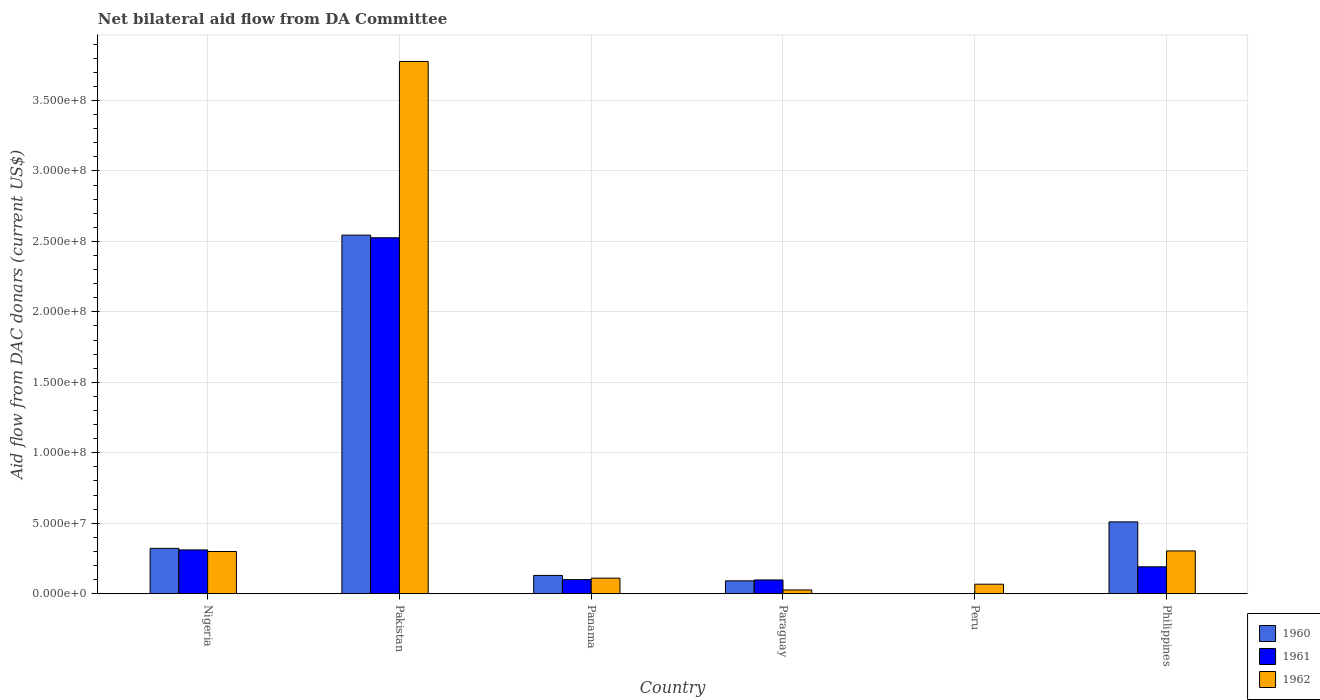How many different coloured bars are there?
Offer a very short reply. 3. What is the label of the 3rd group of bars from the left?
Your answer should be compact. Panama. What is the aid flow in in 1960 in Paraguay?
Your response must be concise. 9.10e+06. Across all countries, what is the maximum aid flow in in 1961?
Provide a succinct answer. 2.53e+08. Across all countries, what is the minimum aid flow in in 1961?
Your response must be concise. 0. In which country was the aid flow in in 1960 maximum?
Offer a very short reply. Pakistan. What is the total aid flow in in 1960 in the graph?
Your response must be concise. 3.60e+08. What is the difference between the aid flow in in 1962 in Pakistan and that in Panama?
Offer a very short reply. 3.67e+08. What is the difference between the aid flow in in 1961 in Peru and the aid flow in in 1960 in Pakistan?
Make the answer very short. -2.54e+08. What is the average aid flow in in 1961 per country?
Your answer should be very brief. 5.37e+07. What is the difference between the aid flow in of/in 1962 and aid flow in of/in 1961 in Nigeria?
Provide a succinct answer. -1.12e+06. In how many countries, is the aid flow in in 1962 greater than 250000000 US$?
Ensure brevity in your answer.  1. What is the ratio of the aid flow in in 1962 in Peru to that in Philippines?
Give a very brief answer. 0.22. Is the aid flow in in 1962 in Panama less than that in Philippines?
Your answer should be compact. Yes. What is the difference between the highest and the second highest aid flow in in 1961?
Keep it short and to the point. 2.22e+08. What is the difference between the highest and the lowest aid flow in in 1961?
Offer a terse response. 2.53e+08. Is it the case that in every country, the sum of the aid flow in in 1961 and aid flow in in 1962 is greater than the aid flow in in 1960?
Provide a short and direct response. No. How many bars are there?
Provide a short and direct response. 16. How many countries are there in the graph?
Your response must be concise. 6. What is the difference between two consecutive major ticks on the Y-axis?
Keep it short and to the point. 5.00e+07. Are the values on the major ticks of Y-axis written in scientific E-notation?
Keep it short and to the point. Yes. Does the graph contain grids?
Offer a terse response. Yes. How are the legend labels stacked?
Ensure brevity in your answer.  Vertical. What is the title of the graph?
Provide a short and direct response. Net bilateral aid flow from DA Committee. Does "1991" appear as one of the legend labels in the graph?
Keep it short and to the point. No. What is the label or title of the Y-axis?
Your answer should be compact. Aid flow from DAC donars (current US$). What is the Aid flow from DAC donars (current US$) of 1960 in Nigeria?
Ensure brevity in your answer.  3.22e+07. What is the Aid flow from DAC donars (current US$) of 1961 in Nigeria?
Provide a succinct answer. 3.10e+07. What is the Aid flow from DAC donars (current US$) in 1962 in Nigeria?
Ensure brevity in your answer.  2.99e+07. What is the Aid flow from DAC donars (current US$) of 1960 in Pakistan?
Provide a short and direct response. 2.54e+08. What is the Aid flow from DAC donars (current US$) in 1961 in Pakistan?
Make the answer very short. 2.53e+08. What is the Aid flow from DAC donars (current US$) in 1962 in Pakistan?
Offer a very short reply. 3.78e+08. What is the Aid flow from DAC donars (current US$) in 1960 in Panama?
Your answer should be very brief. 1.30e+07. What is the Aid flow from DAC donars (current US$) of 1961 in Panama?
Your answer should be very brief. 9.96e+06. What is the Aid flow from DAC donars (current US$) in 1962 in Panama?
Offer a very short reply. 1.10e+07. What is the Aid flow from DAC donars (current US$) in 1960 in Paraguay?
Offer a terse response. 9.10e+06. What is the Aid flow from DAC donars (current US$) in 1961 in Paraguay?
Provide a succinct answer. 9.73e+06. What is the Aid flow from DAC donars (current US$) of 1962 in Paraguay?
Give a very brief answer. 2.62e+06. What is the Aid flow from DAC donars (current US$) of 1962 in Peru?
Provide a succinct answer. 6.72e+06. What is the Aid flow from DAC donars (current US$) of 1960 in Philippines?
Ensure brevity in your answer.  5.09e+07. What is the Aid flow from DAC donars (current US$) in 1961 in Philippines?
Keep it short and to the point. 1.91e+07. What is the Aid flow from DAC donars (current US$) of 1962 in Philippines?
Give a very brief answer. 3.03e+07. Across all countries, what is the maximum Aid flow from DAC donars (current US$) of 1960?
Keep it short and to the point. 2.54e+08. Across all countries, what is the maximum Aid flow from DAC donars (current US$) in 1961?
Provide a short and direct response. 2.53e+08. Across all countries, what is the maximum Aid flow from DAC donars (current US$) in 1962?
Ensure brevity in your answer.  3.78e+08. Across all countries, what is the minimum Aid flow from DAC donars (current US$) of 1961?
Offer a terse response. 0. Across all countries, what is the minimum Aid flow from DAC donars (current US$) of 1962?
Your answer should be compact. 2.62e+06. What is the total Aid flow from DAC donars (current US$) in 1960 in the graph?
Ensure brevity in your answer.  3.60e+08. What is the total Aid flow from DAC donars (current US$) in 1961 in the graph?
Ensure brevity in your answer.  3.22e+08. What is the total Aid flow from DAC donars (current US$) in 1962 in the graph?
Provide a short and direct response. 4.58e+08. What is the difference between the Aid flow from DAC donars (current US$) in 1960 in Nigeria and that in Pakistan?
Offer a very short reply. -2.22e+08. What is the difference between the Aid flow from DAC donars (current US$) of 1961 in Nigeria and that in Pakistan?
Your response must be concise. -2.22e+08. What is the difference between the Aid flow from DAC donars (current US$) in 1962 in Nigeria and that in Pakistan?
Give a very brief answer. -3.48e+08. What is the difference between the Aid flow from DAC donars (current US$) of 1960 in Nigeria and that in Panama?
Keep it short and to the point. 1.92e+07. What is the difference between the Aid flow from DAC donars (current US$) in 1961 in Nigeria and that in Panama?
Your answer should be compact. 2.11e+07. What is the difference between the Aid flow from DAC donars (current US$) of 1962 in Nigeria and that in Panama?
Offer a very short reply. 1.89e+07. What is the difference between the Aid flow from DAC donars (current US$) of 1960 in Nigeria and that in Paraguay?
Provide a short and direct response. 2.31e+07. What is the difference between the Aid flow from DAC donars (current US$) in 1961 in Nigeria and that in Paraguay?
Your answer should be very brief. 2.13e+07. What is the difference between the Aid flow from DAC donars (current US$) of 1962 in Nigeria and that in Paraguay?
Make the answer very short. 2.73e+07. What is the difference between the Aid flow from DAC donars (current US$) in 1962 in Nigeria and that in Peru?
Provide a short and direct response. 2.32e+07. What is the difference between the Aid flow from DAC donars (current US$) in 1960 in Nigeria and that in Philippines?
Keep it short and to the point. -1.88e+07. What is the difference between the Aid flow from DAC donars (current US$) in 1961 in Nigeria and that in Philippines?
Offer a terse response. 1.20e+07. What is the difference between the Aid flow from DAC donars (current US$) of 1962 in Nigeria and that in Philippines?
Your answer should be compact. -4.20e+05. What is the difference between the Aid flow from DAC donars (current US$) of 1960 in Pakistan and that in Panama?
Ensure brevity in your answer.  2.42e+08. What is the difference between the Aid flow from DAC donars (current US$) of 1961 in Pakistan and that in Panama?
Make the answer very short. 2.43e+08. What is the difference between the Aid flow from DAC donars (current US$) in 1962 in Pakistan and that in Panama?
Give a very brief answer. 3.67e+08. What is the difference between the Aid flow from DAC donars (current US$) of 1960 in Pakistan and that in Paraguay?
Keep it short and to the point. 2.45e+08. What is the difference between the Aid flow from DAC donars (current US$) of 1961 in Pakistan and that in Paraguay?
Keep it short and to the point. 2.43e+08. What is the difference between the Aid flow from DAC donars (current US$) of 1962 in Pakistan and that in Paraguay?
Provide a short and direct response. 3.75e+08. What is the difference between the Aid flow from DAC donars (current US$) in 1962 in Pakistan and that in Peru?
Offer a very short reply. 3.71e+08. What is the difference between the Aid flow from DAC donars (current US$) of 1960 in Pakistan and that in Philippines?
Ensure brevity in your answer.  2.04e+08. What is the difference between the Aid flow from DAC donars (current US$) in 1961 in Pakistan and that in Philippines?
Provide a short and direct response. 2.34e+08. What is the difference between the Aid flow from DAC donars (current US$) of 1962 in Pakistan and that in Philippines?
Your answer should be compact. 3.47e+08. What is the difference between the Aid flow from DAC donars (current US$) of 1960 in Panama and that in Paraguay?
Give a very brief answer. 3.86e+06. What is the difference between the Aid flow from DAC donars (current US$) of 1961 in Panama and that in Paraguay?
Make the answer very short. 2.30e+05. What is the difference between the Aid flow from DAC donars (current US$) in 1962 in Panama and that in Paraguay?
Ensure brevity in your answer.  8.39e+06. What is the difference between the Aid flow from DAC donars (current US$) of 1962 in Panama and that in Peru?
Offer a terse response. 4.29e+06. What is the difference between the Aid flow from DAC donars (current US$) of 1960 in Panama and that in Philippines?
Offer a terse response. -3.80e+07. What is the difference between the Aid flow from DAC donars (current US$) in 1961 in Panama and that in Philippines?
Give a very brief answer. -9.10e+06. What is the difference between the Aid flow from DAC donars (current US$) of 1962 in Panama and that in Philippines?
Your answer should be compact. -1.93e+07. What is the difference between the Aid flow from DAC donars (current US$) in 1962 in Paraguay and that in Peru?
Your answer should be compact. -4.10e+06. What is the difference between the Aid flow from DAC donars (current US$) of 1960 in Paraguay and that in Philippines?
Your answer should be very brief. -4.18e+07. What is the difference between the Aid flow from DAC donars (current US$) of 1961 in Paraguay and that in Philippines?
Your answer should be very brief. -9.33e+06. What is the difference between the Aid flow from DAC donars (current US$) in 1962 in Paraguay and that in Philippines?
Make the answer very short. -2.77e+07. What is the difference between the Aid flow from DAC donars (current US$) of 1962 in Peru and that in Philippines?
Provide a succinct answer. -2.36e+07. What is the difference between the Aid flow from DAC donars (current US$) of 1960 in Nigeria and the Aid flow from DAC donars (current US$) of 1961 in Pakistan?
Offer a very short reply. -2.20e+08. What is the difference between the Aid flow from DAC donars (current US$) of 1960 in Nigeria and the Aid flow from DAC donars (current US$) of 1962 in Pakistan?
Your answer should be very brief. -3.46e+08. What is the difference between the Aid flow from DAC donars (current US$) in 1961 in Nigeria and the Aid flow from DAC donars (current US$) in 1962 in Pakistan?
Offer a terse response. -3.47e+08. What is the difference between the Aid flow from DAC donars (current US$) of 1960 in Nigeria and the Aid flow from DAC donars (current US$) of 1961 in Panama?
Your answer should be compact. 2.22e+07. What is the difference between the Aid flow from DAC donars (current US$) of 1960 in Nigeria and the Aid flow from DAC donars (current US$) of 1962 in Panama?
Provide a succinct answer. 2.12e+07. What is the difference between the Aid flow from DAC donars (current US$) of 1961 in Nigeria and the Aid flow from DAC donars (current US$) of 1962 in Panama?
Keep it short and to the point. 2.00e+07. What is the difference between the Aid flow from DAC donars (current US$) of 1960 in Nigeria and the Aid flow from DAC donars (current US$) of 1961 in Paraguay?
Provide a succinct answer. 2.24e+07. What is the difference between the Aid flow from DAC donars (current US$) in 1960 in Nigeria and the Aid flow from DAC donars (current US$) in 1962 in Paraguay?
Ensure brevity in your answer.  2.96e+07. What is the difference between the Aid flow from DAC donars (current US$) of 1961 in Nigeria and the Aid flow from DAC donars (current US$) of 1962 in Paraguay?
Your response must be concise. 2.84e+07. What is the difference between the Aid flow from DAC donars (current US$) in 1960 in Nigeria and the Aid flow from DAC donars (current US$) in 1962 in Peru?
Your answer should be very brief. 2.54e+07. What is the difference between the Aid flow from DAC donars (current US$) in 1961 in Nigeria and the Aid flow from DAC donars (current US$) in 1962 in Peru?
Offer a terse response. 2.43e+07. What is the difference between the Aid flow from DAC donars (current US$) of 1960 in Nigeria and the Aid flow from DAC donars (current US$) of 1961 in Philippines?
Your answer should be very brief. 1.31e+07. What is the difference between the Aid flow from DAC donars (current US$) in 1960 in Nigeria and the Aid flow from DAC donars (current US$) in 1962 in Philippines?
Ensure brevity in your answer.  1.83e+06. What is the difference between the Aid flow from DAC donars (current US$) in 1960 in Pakistan and the Aid flow from DAC donars (current US$) in 1961 in Panama?
Give a very brief answer. 2.45e+08. What is the difference between the Aid flow from DAC donars (current US$) of 1960 in Pakistan and the Aid flow from DAC donars (current US$) of 1962 in Panama?
Offer a very short reply. 2.43e+08. What is the difference between the Aid flow from DAC donars (current US$) in 1961 in Pakistan and the Aid flow from DAC donars (current US$) in 1962 in Panama?
Your answer should be very brief. 2.42e+08. What is the difference between the Aid flow from DAC donars (current US$) in 1960 in Pakistan and the Aid flow from DAC donars (current US$) in 1961 in Paraguay?
Your answer should be compact. 2.45e+08. What is the difference between the Aid flow from DAC donars (current US$) of 1960 in Pakistan and the Aid flow from DAC donars (current US$) of 1962 in Paraguay?
Provide a succinct answer. 2.52e+08. What is the difference between the Aid flow from DAC donars (current US$) of 1961 in Pakistan and the Aid flow from DAC donars (current US$) of 1962 in Paraguay?
Provide a succinct answer. 2.50e+08. What is the difference between the Aid flow from DAC donars (current US$) in 1960 in Pakistan and the Aid flow from DAC donars (current US$) in 1962 in Peru?
Provide a short and direct response. 2.48e+08. What is the difference between the Aid flow from DAC donars (current US$) in 1961 in Pakistan and the Aid flow from DAC donars (current US$) in 1962 in Peru?
Make the answer very short. 2.46e+08. What is the difference between the Aid flow from DAC donars (current US$) of 1960 in Pakistan and the Aid flow from DAC donars (current US$) of 1961 in Philippines?
Your response must be concise. 2.35e+08. What is the difference between the Aid flow from DAC donars (current US$) of 1960 in Pakistan and the Aid flow from DAC donars (current US$) of 1962 in Philippines?
Keep it short and to the point. 2.24e+08. What is the difference between the Aid flow from DAC donars (current US$) of 1961 in Pakistan and the Aid flow from DAC donars (current US$) of 1962 in Philippines?
Ensure brevity in your answer.  2.22e+08. What is the difference between the Aid flow from DAC donars (current US$) of 1960 in Panama and the Aid flow from DAC donars (current US$) of 1961 in Paraguay?
Provide a short and direct response. 3.23e+06. What is the difference between the Aid flow from DAC donars (current US$) in 1960 in Panama and the Aid flow from DAC donars (current US$) in 1962 in Paraguay?
Ensure brevity in your answer.  1.03e+07. What is the difference between the Aid flow from DAC donars (current US$) of 1961 in Panama and the Aid flow from DAC donars (current US$) of 1962 in Paraguay?
Give a very brief answer. 7.34e+06. What is the difference between the Aid flow from DAC donars (current US$) of 1960 in Panama and the Aid flow from DAC donars (current US$) of 1962 in Peru?
Provide a succinct answer. 6.24e+06. What is the difference between the Aid flow from DAC donars (current US$) of 1961 in Panama and the Aid flow from DAC donars (current US$) of 1962 in Peru?
Make the answer very short. 3.24e+06. What is the difference between the Aid flow from DAC donars (current US$) of 1960 in Panama and the Aid flow from DAC donars (current US$) of 1961 in Philippines?
Your answer should be very brief. -6.10e+06. What is the difference between the Aid flow from DAC donars (current US$) in 1960 in Panama and the Aid flow from DAC donars (current US$) in 1962 in Philippines?
Offer a very short reply. -1.74e+07. What is the difference between the Aid flow from DAC donars (current US$) in 1961 in Panama and the Aid flow from DAC donars (current US$) in 1962 in Philippines?
Ensure brevity in your answer.  -2.04e+07. What is the difference between the Aid flow from DAC donars (current US$) of 1960 in Paraguay and the Aid flow from DAC donars (current US$) of 1962 in Peru?
Your response must be concise. 2.38e+06. What is the difference between the Aid flow from DAC donars (current US$) in 1961 in Paraguay and the Aid flow from DAC donars (current US$) in 1962 in Peru?
Keep it short and to the point. 3.01e+06. What is the difference between the Aid flow from DAC donars (current US$) of 1960 in Paraguay and the Aid flow from DAC donars (current US$) of 1961 in Philippines?
Your response must be concise. -9.96e+06. What is the difference between the Aid flow from DAC donars (current US$) in 1960 in Paraguay and the Aid flow from DAC donars (current US$) in 1962 in Philippines?
Provide a short and direct response. -2.12e+07. What is the difference between the Aid flow from DAC donars (current US$) of 1961 in Paraguay and the Aid flow from DAC donars (current US$) of 1962 in Philippines?
Your answer should be very brief. -2.06e+07. What is the average Aid flow from DAC donars (current US$) in 1960 per country?
Ensure brevity in your answer.  5.99e+07. What is the average Aid flow from DAC donars (current US$) in 1961 per country?
Give a very brief answer. 5.37e+07. What is the average Aid flow from DAC donars (current US$) in 1962 per country?
Ensure brevity in your answer.  7.64e+07. What is the difference between the Aid flow from DAC donars (current US$) of 1960 and Aid flow from DAC donars (current US$) of 1961 in Nigeria?
Your answer should be very brief. 1.13e+06. What is the difference between the Aid flow from DAC donars (current US$) of 1960 and Aid flow from DAC donars (current US$) of 1962 in Nigeria?
Give a very brief answer. 2.25e+06. What is the difference between the Aid flow from DAC donars (current US$) in 1961 and Aid flow from DAC donars (current US$) in 1962 in Nigeria?
Your answer should be compact. 1.12e+06. What is the difference between the Aid flow from DAC donars (current US$) of 1960 and Aid flow from DAC donars (current US$) of 1961 in Pakistan?
Offer a very short reply. 1.87e+06. What is the difference between the Aid flow from DAC donars (current US$) in 1960 and Aid flow from DAC donars (current US$) in 1962 in Pakistan?
Your answer should be compact. -1.23e+08. What is the difference between the Aid flow from DAC donars (current US$) of 1961 and Aid flow from DAC donars (current US$) of 1962 in Pakistan?
Your answer should be compact. -1.25e+08. What is the difference between the Aid flow from DAC donars (current US$) in 1960 and Aid flow from DAC donars (current US$) in 1962 in Panama?
Your response must be concise. 1.95e+06. What is the difference between the Aid flow from DAC donars (current US$) of 1961 and Aid flow from DAC donars (current US$) of 1962 in Panama?
Provide a succinct answer. -1.05e+06. What is the difference between the Aid flow from DAC donars (current US$) in 1960 and Aid flow from DAC donars (current US$) in 1961 in Paraguay?
Provide a short and direct response. -6.30e+05. What is the difference between the Aid flow from DAC donars (current US$) of 1960 and Aid flow from DAC donars (current US$) of 1962 in Paraguay?
Your answer should be very brief. 6.48e+06. What is the difference between the Aid flow from DAC donars (current US$) in 1961 and Aid flow from DAC donars (current US$) in 1962 in Paraguay?
Offer a very short reply. 7.11e+06. What is the difference between the Aid flow from DAC donars (current US$) in 1960 and Aid flow from DAC donars (current US$) in 1961 in Philippines?
Your answer should be very brief. 3.19e+07. What is the difference between the Aid flow from DAC donars (current US$) of 1960 and Aid flow from DAC donars (current US$) of 1962 in Philippines?
Keep it short and to the point. 2.06e+07. What is the difference between the Aid flow from DAC donars (current US$) in 1961 and Aid flow from DAC donars (current US$) in 1962 in Philippines?
Make the answer very short. -1.13e+07. What is the ratio of the Aid flow from DAC donars (current US$) of 1960 in Nigeria to that in Pakistan?
Provide a succinct answer. 0.13. What is the ratio of the Aid flow from DAC donars (current US$) of 1961 in Nigeria to that in Pakistan?
Keep it short and to the point. 0.12. What is the ratio of the Aid flow from DAC donars (current US$) in 1962 in Nigeria to that in Pakistan?
Provide a succinct answer. 0.08. What is the ratio of the Aid flow from DAC donars (current US$) in 1960 in Nigeria to that in Panama?
Make the answer very short. 2.48. What is the ratio of the Aid flow from DAC donars (current US$) of 1961 in Nigeria to that in Panama?
Offer a very short reply. 3.12. What is the ratio of the Aid flow from DAC donars (current US$) of 1962 in Nigeria to that in Panama?
Give a very brief answer. 2.72. What is the ratio of the Aid flow from DAC donars (current US$) in 1960 in Nigeria to that in Paraguay?
Offer a terse response. 3.54. What is the ratio of the Aid flow from DAC donars (current US$) in 1961 in Nigeria to that in Paraguay?
Offer a very short reply. 3.19. What is the ratio of the Aid flow from DAC donars (current US$) of 1962 in Nigeria to that in Paraguay?
Make the answer very short. 11.42. What is the ratio of the Aid flow from DAC donars (current US$) of 1962 in Nigeria to that in Peru?
Your answer should be very brief. 4.45. What is the ratio of the Aid flow from DAC donars (current US$) in 1960 in Nigeria to that in Philippines?
Make the answer very short. 0.63. What is the ratio of the Aid flow from DAC donars (current US$) in 1961 in Nigeria to that in Philippines?
Provide a short and direct response. 1.63. What is the ratio of the Aid flow from DAC donars (current US$) of 1962 in Nigeria to that in Philippines?
Provide a short and direct response. 0.99. What is the ratio of the Aid flow from DAC donars (current US$) in 1960 in Pakistan to that in Panama?
Offer a very short reply. 19.64. What is the ratio of the Aid flow from DAC donars (current US$) of 1961 in Pakistan to that in Panama?
Offer a very short reply. 25.36. What is the ratio of the Aid flow from DAC donars (current US$) of 1962 in Pakistan to that in Panama?
Your answer should be very brief. 34.31. What is the ratio of the Aid flow from DAC donars (current US$) in 1960 in Pakistan to that in Paraguay?
Keep it short and to the point. 27.96. What is the ratio of the Aid flow from DAC donars (current US$) of 1961 in Pakistan to that in Paraguay?
Keep it short and to the point. 25.96. What is the ratio of the Aid flow from DAC donars (current US$) in 1962 in Pakistan to that in Paraguay?
Your response must be concise. 144.16. What is the ratio of the Aid flow from DAC donars (current US$) in 1962 in Pakistan to that in Peru?
Provide a succinct answer. 56.21. What is the ratio of the Aid flow from DAC donars (current US$) of 1960 in Pakistan to that in Philippines?
Keep it short and to the point. 5. What is the ratio of the Aid flow from DAC donars (current US$) of 1961 in Pakistan to that in Philippines?
Offer a terse response. 13.25. What is the ratio of the Aid flow from DAC donars (current US$) of 1962 in Pakistan to that in Philippines?
Keep it short and to the point. 12.45. What is the ratio of the Aid flow from DAC donars (current US$) in 1960 in Panama to that in Paraguay?
Offer a very short reply. 1.42. What is the ratio of the Aid flow from DAC donars (current US$) of 1961 in Panama to that in Paraguay?
Provide a short and direct response. 1.02. What is the ratio of the Aid flow from DAC donars (current US$) in 1962 in Panama to that in Paraguay?
Your answer should be very brief. 4.2. What is the ratio of the Aid flow from DAC donars (current US$) of 1962 in Panama to that in Peru?
Provide a short and direct response. 1.64. What is the ratio of the Aid flow from DAC donars (current US$) of 1960 in Panama to that in Philippines?
Your answer should be compact. 0.25. What is the ratio of the Aid flow from DAC donars (current US$) of 1961 in Panama to that in Philippines?
Provide a succinct answer. 0.52. What is the ratio of the Aid flow from DAC donars (current US$) in 1962 in Panama to that in Philippines?
Your answer should be compact. 0.36. What is the ratio of the Aid flow from DAC donars (current US$) of 1962 in Paraguay to that in Peru?
Your answer should be compact. 0.39. What is the ratio of the Aid flow from DAC donars (current US$) in 1960 in Paraguay to that in Philippines?
Offer a very short reply. 0.18. What is the ratio of the Aid flow from DAC donars (current US$) in 1961 in Paraguay to that in Philippines?
Provide a short and direct response. 0.51. What is the ratio of the Aid flow from DAC donars (current US$) of 1962 in Paraguay to that in Philippines?
Offer a very short reply. 0.09. What is the ratio of the Aid flow from DAC donars (current US$) in 1962 in Peru to that in Philippines?
Give a very brief answer. 0.22. What is the difference between the highest and the second highest Aid flow from DAC donars (current US$) in 1960?
Provide a succinct answer. 2.04e+08. What is the difference between the highest and the second highest Aid flow from DAC donars (current US$) in 1961?
Provide a succinct answer. 2.22e+08. What is the difference between the highest and the second highest Aid flow from DAC donars (current US$) of 1962?
Offer a terse response. 3.47e+08. What is the difference between the highest and the lowest Aid flow from DAC donars (current US$) in 1960?
Give a very brief answer. 2.54e+08. What is the difference between the highest and the lowest Aid flow from DAC donars (current US$) in 1961?
Offer a terse response. 2.53e+08. What is the difference between the highest and the lowest Aid flow from DAC donars (current US$) in 1962?
Provide a short and direct response. 3.75e+08. 